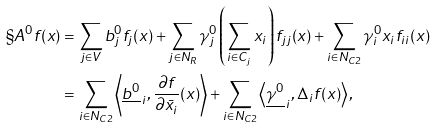Convert formula to latex. <formula><loc_0><loc_0><loc_500><loc_500>\S A ^ { 0 } f ( x ) & = \sum _ { j \in V } b _ { j } ^ { 0 } f _ { j } ( x ) + \sum _ { j \in N _ { R } } \gamma _ { j } ^ { 0 } \left ( \sum _ { i \in C _ { j } } x _ { i } \right ) f _ { j j } ( x ) + \sum _ { i \in N _ { C 2 } } \gamma _ { i } ^ { 0 } x _ { i } f _ { i i } ( x ) \\ & = \sum _ { i \in N _ { C 2 } } \left \langle \underline { b ^ { 0 } } _ { \, i } , \frac { \partial f } { \partial \bar { x } _ { i } } ( x ) \right \rangle + \sum _ { i \in N _ { C 2 } } \left \langle \underline { \gamma ^ { 0 } } _ { \, i } , \Delta _ { i } f ( x ) \right \rangle ,</formula> 